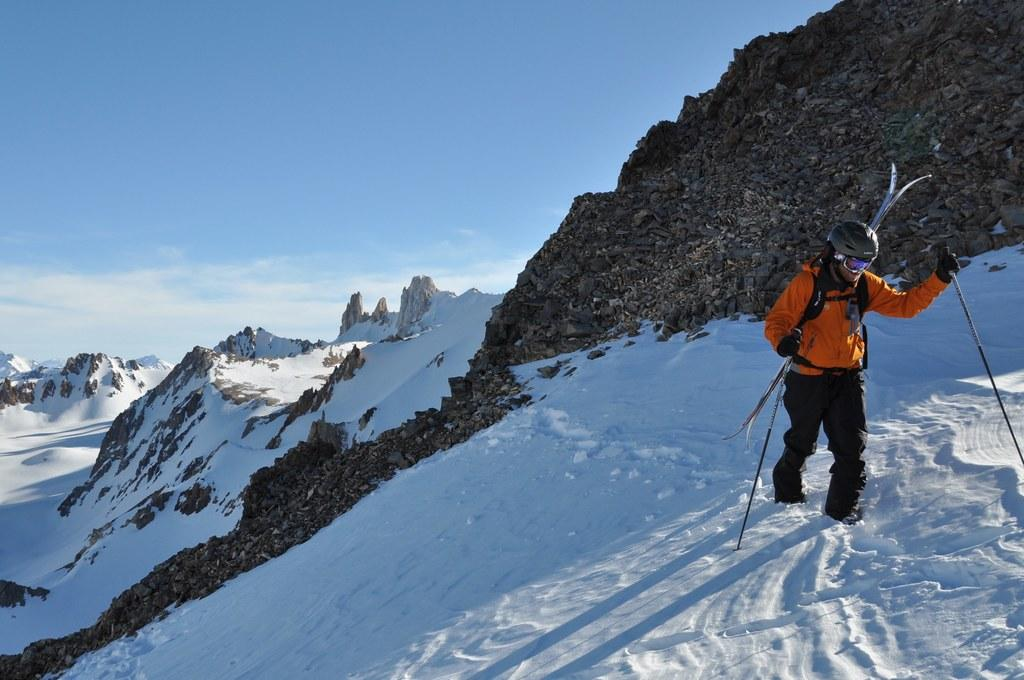What is present in the image? There is a person in the image. What is the person holding in the image? The person is holding an object. What type of natural landscape can be seen in the image? There are mountains visible in the image. What is the weather like in the image? There is snow in the image, which suggests a cold or snowy environment. What is visible in the sky in the image? The sky is visible in the image. Can you see any sheets or boots in the image? There is no mention of sheets or boots in the image. Are there any ants visible in the image? There is no mention of ants in the image. 